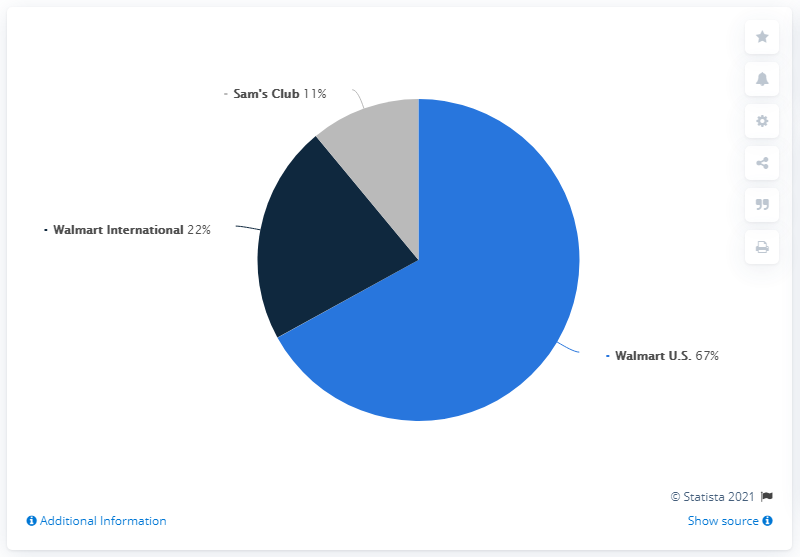Mention a couple of crucial points in this snapshot. The majority of Walmart's sales have been contributed by Walmart U.S. 